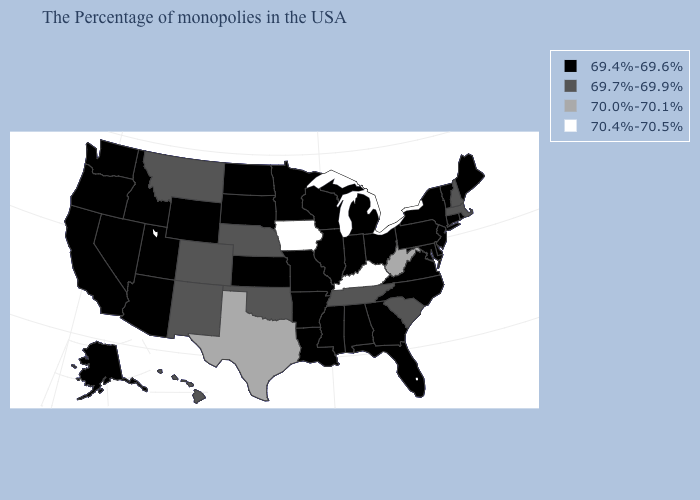Name the states that have a value in the range 69.7%-69.9%?
Give a very brief answer. Massachusetts, New Hampshire, South Carolina, Tennessee, Nebraska, Oklahoma, Colorado, New Mexico, Montana, Hawaii. Which states have the lowest value in the MidWest?
Concise answer only. Ohio, Michigan, Indiana, Wisconsin, Illinois, Missouri, Minnesota, Kansas, South Dakota, North Dakota. Does Iowa have a higher value than Delaware?
Keep it brief. Yes. Name the states that have a value in the range 70.0%-70.1%?
Concise answer only. West Virginia, Texas. Name the states that have a value in the range 69.7%-69.9%?
Concise answer only. Massachusetts, New Hampshire, South Carolina, Tennessee, Nebraska, Oklahoma, Colorado, New Mexico, Montana, Hawaii. Name the states that have a value in the range 69.7%-69.9%?
Be succinct. Massachusetts, New Hampshire, South Carolina, Tennessee, Nebraska, Oklahoma, Colorado, New Mexico, Montana, Hawaii. What is the lowest value in the West?
Concise answer only. 69.4%-69.6%. Which states have the lowest value in the South?
Give a very brief answer. Delaware, Maryland, Virginia, North Carolina, Florida, Georgia, Alabama, Mississippi, Louisiana, Arkansas. What is the lowest value in states that border Arkansas?
Keep it brief. 69.4%-69.6%. Name the states that have a value in the range 69.7%-69.9%?
Concise answer only. Massachusetts, New Hampshire, South Carolina, Tennessee, Nebraska, Oklahoma, Colorado, New Mexico, Montana, Hawaii. Name the states that have a value in the range 70.0%-70.1%?
Write a very short answer. West Virginia, Texas. Name the states that have a value in the range 69.4%-69.6%?
Keep it brief. Maine, Rhode Island, Vermont, Connecticut, New York, New Jersey, Delaware, Maryland, Pennsylvania, Virginia, North Carolina, Ohio, Florida, Georgia, Michigan, Indiana, Alabama, Wisconsin, Illinois, Mississippi, Louisiana, Missouri, Arkansas, Minnesota, Kansas, South Dakota, North Dakota, Wyoming, Utah, Arizona, Idaho, Nevada, California, Washington, Oregon, Alaska. Does the first symbol in the legend represent the smallest category?
Concise answer only. Yes. Among the states that border Washington , which have the highest value?
Answer briefly. Idaho, Oregon. 